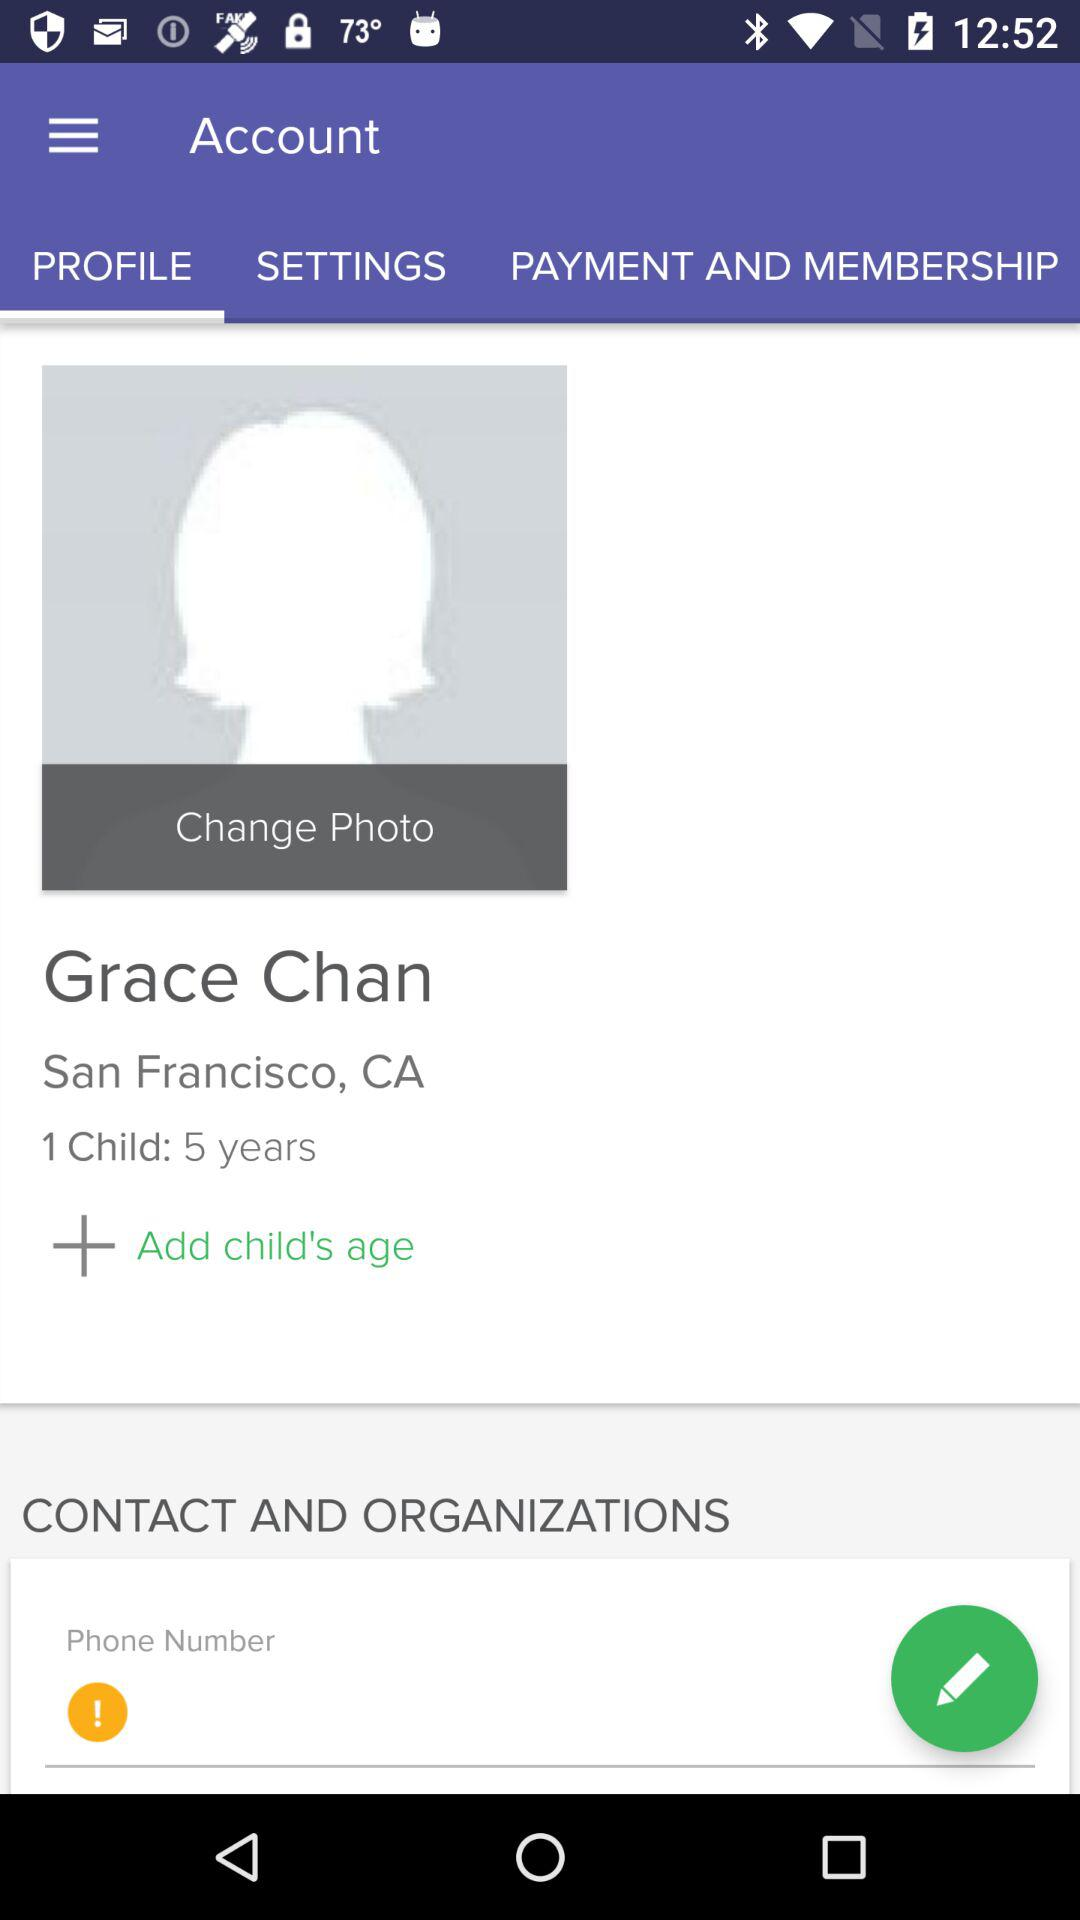What is the age of Grace's child? The age of Grace's child is 5 years. 